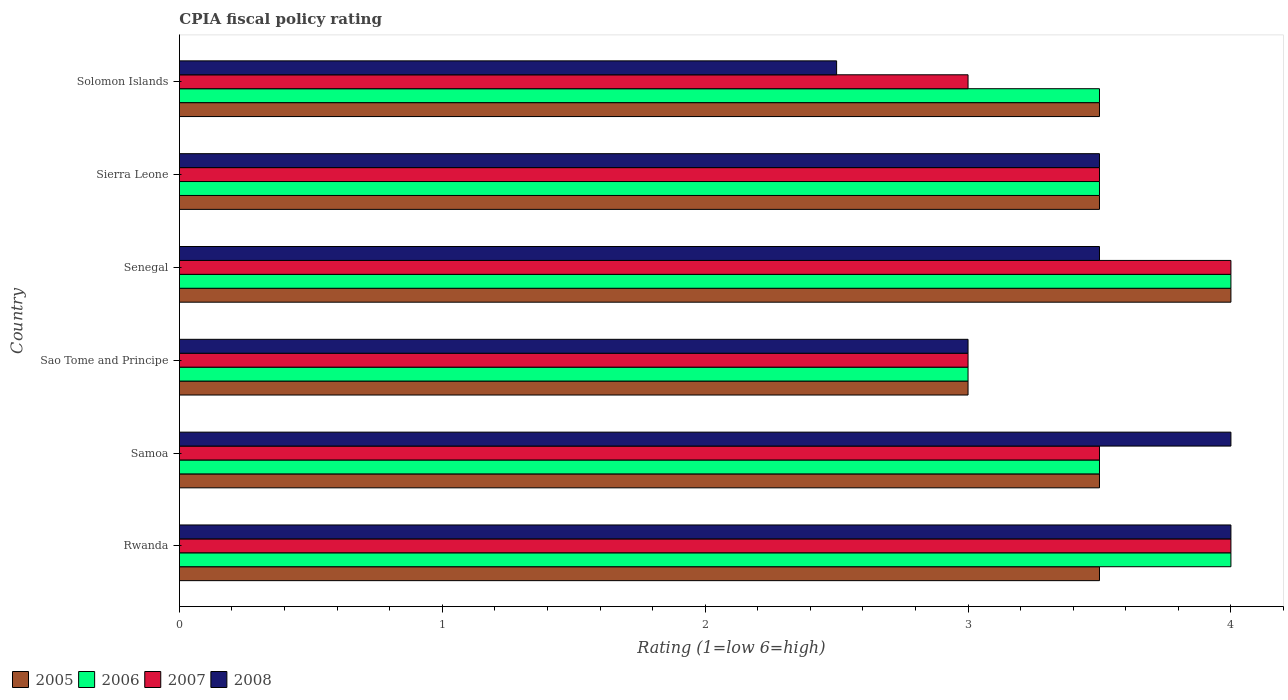How many different coloured bars are there?
Provide a short and direct response. 4. How many groups of bars are there?
Give a very brief answer. 6. How many bars are there on the 2nd tick from the top?
Provide a succinct answer. 4. What is the label of the 4th group of bars from the top?
Your answer should be compact. Sao Tome and Principe. What is the CPIA rating in 2005 in Sierra Leone?
Provide a succinct answer. 3.5. Across all countries, what is the maximum CPIA rating in 2008?
Offer a very short reply. 4. In which country was the CPIA rating in 2008 maximum?
Your answer should be very brief. Rwanda. In which country was the CPIA rating in 2005 minimum?
Provide a short and direct response. Sao Tome and Principe. What is the difference between the CPIA rating in 2008 in Rwanda and that in Samoa?
Your response must be concise. 0. What is the average CPIA rating in 2006 per country?
Provide a succinct answer. 3.58. In how many countries, is the CPIA rating in 2006 greater than 1 ?
Your response must be concise. 6. What is the ratio of the CPIA rating in 2005 in Senegal to that in Sierra Leone?
Make the answer very short. 1.14. Is the difference between the CPIA rating in 2006 in Sierra Leone and Solomon Islands greater than the difference between the CPIA rating in 2008 in Sierra Leone and Solomon Islands?
Make the answer very short. No. What is the difference between the highest and the second highest CPIA rating in 2008?
Keep it short and to the point. 0. What is the difference between the highest and the lowest CPIA rating in 2007?
Give a very brief answer. 1. In how many countries, is the CPIA rating in 2005 greater than the average CPIA rating in 2005 taken over all countries?
Offer a terse response. 1. What does the 2nd bar from the top in Solomon Islands represents?
Your answer should be compact. 2007. What does the 2nd bar from the bottom in Sierra Leone represents?
Keep it short and to the point. 2006. Is it the case that in every country, the sum of the CPIA rating in 2006 and CPIA rating in 2008 is greater than the CPIA rating in 2005?
Ensure brevity in your answer.  Yes. What is the difference between two consecutive major ticks on the X-axis?
Your response must be concise. 1. Does the graph contain any zero values?
Your answer should be very brief. No. Does the graph contain grids?
Provide a succinct answer. No. Where does the legend appear in the graph?
Provide a short and direct response. Bottom left. How are the legend labels stacked?
Your answer should be compact. Horizontal. What is the title of the graph?
Your answer should be compact. CPIA fiscal policy rating. Does "2001" appear as one of the legend labels in the graph?
Your response must be concise. No. What is the Rating (1=low 6=high) in 2005 in Rwanda?
Keep it short and to the point. 3.5. What is the Rating (1=low 6=high) of 2006 in Rwanda?
Make the answer very short. 4. What is the Rating (1=low 6=high) of 2005 in Samoa?
Your answer should be very brief. 3.5. What is the Rating (1=low 6=high) of 2006 in Samoa?
Give a very brief answer. 3.5. What is the Rating (1=low 6=high) in 2008 in Samoa?
Your answer should be very brief. 4. What is the Rating (1=low 6=high) of 2007 in Sao Tome and Principe?
Offer a very short reply. 3. What is the Rating (1=low 6=high) of 2008 in Sao Tome and Principe?
Give a very brief answer. 3. What is the Rating (1=low 6=high) of 2005 in Senegal?
Make the answer very short. 4. What is the Rating (1=low 6=high) in 2007 in Senegal?
Your answer should be very brief. 4. What is the Rating (1=low 6=high) in 2008 in Senegal?
Ensure brevity in your answer.  3.5. What is the Rating (1=low 6=high) in 2005 in Sierra Leone?
Offer a very short reply. 3.5. What is the Rating (1=low 6=high) in 2007 in Sierra Leone?
Provide a succinct answer. 3.5. What is the Rating (1=low 6=high) of 2006 in Solomon Islands?
Provide a short and direct response. 3.5. What is the Rating (1=low 6=high) in 2008 in Solomon Islands?
Keep it short and to the point. 2.5. Across all countries, what is the minimum Rating (1=low 6=high) in 2007?
Ensure brevity in your answer.  3. What is the difference between the Rating (1=low 6=high) of 2006 in Rwanda and that in Samoa?
Provide a succinct answer. 0.5. What is the difference between the Rating (1=low 6=high) of 2008 in Rwanda and that in Samoa?
Offer a very short reply. 0. What is the difference between the Rating (1=low 6=high) in 2006 in Rwanda and that in Sao Tome and Principe?
Ensure brevity in your answer.  1. What is the difference between the Rating (1=low 6=high) of 2008 in Rwanda and that in Sao Tome and Principe?
Keep it short and to the point. 1. What is the difference between the Rating (1=low 6=high) in 2008 in Rwanda and that in Senegal?
Your answer should be very brief. 0.5. What is the difference between the Rating (1=low 6=high) in 2005 in Rwanda and that in Sierra Leone?
Provide a short and direct response. 0. What is the difference between the Rating (1=low 6=high) in 2006 in Rwanda and that in Sierra Leone?
Provide a succinct answer. 0.5. What is the difference between the Rating (1=low 6=high) of 2007 in Rwanda and that in Sierra Leone?
Keep it short and to the point. 0.5. What is the difference between the Rating (1=low 6=high) in 2007 in Rwanda and that in Solomon Islands?
Your answer should be very brief. 1. What is the difference between the Rating (1=low 6=high) of 2005 in Samoa and that in Sao Tome and Principe?
Make the answer very short. 0.5. What is the difference between the Rating (1=low 6=high) in 2007 in Samoa and that in Sao Tome and Principe?
Your answer should be compact. 0.5. What is the difference between the Rating (1=low 6=high) of 2008 in Samoa and that in Sao Tome and Principe?
Give a very brief answer. 1. What is the difference between the Rating (1=low 6=high) in 2006 in Samoa and that in Senegal?
Make the answer very short. -0.5. What is the difference between the Rating (1=low 6=high) in 2007 in Samoa and that in Sierra Leone?
Provide a short and direct response. 0. What is the difference between the Rating (1=low 6=high) in 2005 in Samoa and that in Solomon Islands?
Your answer should be very brief. 0. What is the difference between the Rating (1=low 6=high) of 2006 in Samoa and that in Solomon Islands?
Your answer should be compact. 0. What is the difference between the Rating (1=low 6=high) in 2008 in Samoa and that in Solomon Islands?
Your answer should be compact. 1.5. What is the difference between the Rating (1=low 6=high) of 2006 in Sao Tome and Principe and that in Sierra Leone?
Offer a very short reply. -0.5. What is the difference between the Rating (1=low 6=high) in 2007 in Sao Tome and Principe and that in Sierra Leone?
Give a very brief answer. -0.5. What is the difference between the Rating (1=low 6=high) of 2008 in Sao Tome and Principe and that in Sierra Leone?
Your response must be concise. -0.5. What is the difference between the Rating (1=low 6=high) in 2006 in Sao Tome and Principe and that in Solomon Islands?
Offer a terse response. -0.5. What is the difference between the Rating (1=low 6=high) of 2008 in Sao Tome and Principe and that in Solomon Islands?
Provide a succinct answer. 0.5. What is the difference between the Rating (1=low 6=high) in 2005 in Senegal and that in Sierra Leone?
Ensure brevity in your answer.  0.5. What is the difference between the Rating (1=low 6=high) in 2006 in Senegal and that in Sierra Leone?
Offer a terse response. 0.5. What is the difference between the Rating (1=low 6=high) in 2008 in Senegal and that in Sierra Leone?
Make the answer very short. 0. What is the difference between the Rating (1=low 6=high) of 2007 in Senegal and that in Solomon Islands?
Your response must be concise. 1. What is the difference between the Rating (1=low 6=high) of 2007 in Sierra Leone and that in Solomon Islands?
Offer a terse response. 0.5. What is the difference between the Rating (1=low 6=high) of 2005 in Rwanda and the Rating (1=low 6=high) of 2006 in Samoa?
Provide a succinct answer. 0. What is the difference between the Rating (1=low 6=high) in 2005 in Rwanda and the Rating (1=low 6=high) in 2007 in Samoa?
Provide a succinct answer. 0. What is the difference between the Rating (1=low 6=high) in 2005 in Rwanda and the Rating (1=low 6=high) in 2008 in Samoa?
Provide a short and direct response. -0.5. What is the difference between the Rating (1=low 6=high) in 2006 in Rwanda and the Rating (1=low 6=high) in 2007 in Samoa?
Keep it short and to the point. 0.5. What is the difference between the Rating (1=low 6=high) of 2006 in Rwanda and the Rating (1=low 6=high) of 2008 in Samoa?
Your answer should be compact. 0. What is the difference between the Rating (1=low 6=high) of 2006 in Rwanda and the Rating (1=low 6=high) of 2007 in Sao Tome and Principe?
Provide a short and direct response. 1. What is the difference between the Rating (1=low 6=high) in 2005 in Rwanda and the Rating (1=low 6=high) in 2007 in Senegal?
Provide a short and direct response. -0.5. What is the difference between the Rating (1=low 6=high) in 2005 in Rwanda and the Rating (1=low 6=high) in 2008 in Senegal?
Ensure brevity in your answer.  0. What is the difference between the Rating (1=low 6=high) in 2006 in Rwanda and the Rating (1=low 6=high) in 2008 in Senegal?
Offer a very short reply. 0.5. What is the difference between the Rating (1=low 6=high) of 2007 in Rwanda and the Rating (1=low 6=high) of 2008 in Senegal?
Your response must be concise. 0.5. What is the difference between the Rating (1=low 6=high) in 2006 in Rwanda and the Rating (1=low 6=high) in 2007 in Sierra Leone?
Your response must be concise. 0.5. What is the difference between the Rating (1=low 6=high) in 2006 in Rwanda and the Rating (1=low 6=high) in 2008 in Sierra Leone?
Your answer should be compact. 0.5. What is the difference between the Rating (1=low 6=high) of 2007 in Rwanda and the Rating (1=low 6=high) of 2008 in Sierra Leone?
Your response must be concise. 0.5. What is the difference between the Rating (1=low 6=high) of 2005 in Rwanda and the Rating (1=low 6=high) of 2007 in Solomon Islands?
Make the answer very short. 0.5. What is the difference between the Rating (1=low 6=high) in 2006 in Samoa and the Rating (1=low 6=high) in 2008 in Sao Tome and Principe?
Your answer should be very brief. 0.5. What is the difference between the Rating (1=low 6=high) of 2007 in Samoa and the Rating (1=low 6=high) of 2008 in Sao Tome and Principe?
Give a very brief answer. 0.5. What is the difference between the Rating (1=low 6=high) in 2005 in Samoa and the Rating (1=low 6=high) in 2006 in Senegal?
Provide a succinct answer. -0.5. What is the difference between the Rating (1=low 6=high) of 2005 in Samoa and the Rating (1=low 6=high) of 2007 in Senegal?
Offer a very short reply. -0.5. What is the difference between the Rating (1=low 6=high) in 2005 in Samoa and the Rating (1=low 6=high) in 2008 in Senegal?
Offer a very short reply. 0. What is the difference between the Rating (1=low 6=high) of 2006 in Samoa and the Rating (1=low 6=high) of 2007 in Senegal?
Provide a succinct answer. -0.5. What is the difference between the Rating (1=low 6=high) in 2006 in Samoa and the Rating (1=low 6=high) in 2008 in Senegal?
Give a very brief answer. 0. What is the difference between the Rating (1=low 6=high) of 2005 in Samoa and the Rating (1=low 6=high) of 2007 in Sierra Leone?
Your answer should be compact. 0. What is the difference between the Rating (1=low 6=high) in 2005 in Samoa and the Rating (1=low 6=high) in 2008 in Sierra Leone?
Offer a very short reply. 0. What is the difference between the Rating (1=low 6=high) in 2006 in Samoa and the Rating (1=low 6=high) in 2008 in Sierra Leone?
Your response must be concise. 0. What is the difference between the Rating (1=low 6=high) of 2005 in Samoa and the Rating (1=low 6=high) of 2006 in Solomon Islands?
Offer a very short reply. 0. What is the difference between the Rating (1=low 6=high) in 2006 in Samoa and the Rating (1=low 6=high) in 2008 in Solomon Islands?
Offer a terse response. 1. What is the difference between the Rating (1=low 6=high) in 2007 in Samoa and the Rating (1=low 6=high) in 2008 in Solomon Islands?
Provide a short and direct response. 1. What is the difference between the Rating (1=low 6=high) in 2006 in Sao Tome and Principe and the Rating (1=low 6=high) in 2007 in Senegal?
Provide a succinct answer. -1. What is the difference between the Rating (1=low 6=high) of 2005 in Sao Tome and Principe and the Rating (1=low 6=high) of 2006 in Sierra Leone?
Your response must be concise. -0.5. What is the difference between the Rating (1=low 6=high) of 2005 in Sao Tome and Principe and the Rating (1=low 6=high) of 2008 in Sierra Leone?
Your response must be concise. -0.5. What is the difference between the Rating (1=low 6=high) in 2006 in Sao Tome and Principe and the Rating (1=low 6=high) in 2007 in Sierra Leone?
Keep it short and to the point. -0.5. What is the difference between the Rating (1=low 6=high) of 2006 in Sao Tome and Principe and the Rating (1=low 6=high) of 2008 in Sierra Leone?
Your answer should be very brief. -0.5. What is the difference between the Rating (1=low 6=high) in 2007 in Sao Tome and Principe and the Rating (1=low 6=high) in 2008 in Sierra Leone?
Provide a succinct answer. -0.5. What is the difference between the Rating (1=low 6=high) in 2005 in Sao Tome and Principe and the Rating (1=low 6=high) in 2008 in Solomon Islands?
Offer a very short reply. 0.5. What is the difference between the Rating (1=low 6=high) in 2006 in Sao Tome and Principe and the Rating (1=low 6=high) in 2007 in Solomon Islands?
Provide a short and direct response. 0. What is the difference between the Rating (1=low 6=high) of 2007 in Sao Tome and Principe and the Rating (1=low 6=high) of 2008 in Solomon Islands?
Offer a terse response. 0.5. What is the difference between the Rating (1=low 6=high) of 2005 in Senegal and the Rating (1=low 6=high) of 2007 in Sierra Leone?
Offer a terse response. 0.5. What is the difference between the Rating (1=low 6=high) in 2005 in Senegal and the Rating (1=low 6=high) in 2008 in Sierra Leone?
Ensure brevity in your answer.  0.5. What is the difference between the Rating (1=low 6=high) of 2005 in Senegal and the Rating (1=low 6=high) of 2006 in Solomon Islands?
Make the answer very short. 0.5. What is the difference between the Rating (1=low 6=high) in 2005 in Senegal and the Rating (1=low 6=high) in 2008 in Solomon Islands?
Provide a short and direct response. 1.5. What is the difference between the Rating (1=low 6=high) of 2006 in Senegal and the Rating (1=low 6=high) of 2007 in Solomon Islands?
Give a very brief answer. 1. What is the difference between the Rating (1=low 6=high) of 2006 in Senegal and the Rating (1=low 6=high) of 2008 in Solomon Islands?
Provide a short and direct response. 1.5. What is the difference between the Rating (1=low 6=high) in 2005 in Sierra Leone and the Rating (1=low 6=high) in 2006 in Solomon Islands?
Offer a very short reply. 0. What is the difference between the Rating (1=low 6=high) of 2005 in Sierra Leone and the Rating (1=low 6=high) of 2007 in Solomon Islands?
Keep it short and to the point. 0.5. What is the difference between the Rating (1=low 6=high) in 2005 in Sierra Leone and the Rating (1=low 6=high) in 2008 in Solomon Islands?
Make the answer very short. 1. What is the difference between the Rating (1=low 6=high) in 2007 in Sierra Leone and the Rating (1=low 6=high) in 2008 in Solomon Islands?
Give a very brief answer. 1. What is the average Rating (1=low 6=high) in 2005 per country?
Your answer should be very brief. 3.5. What is the average Rating (1=low 6=high) of 2006 per country?
Your response must be concise. 3.58. What is the average Rating (1=low 6=high) of 2008 per country?
Keep it short and to the point. 3.42. What is the difference between the Rating (1=low 6=high) of 2005 and Rating (1=low 6=high) of 2006 in Rwanda?
Your response must be concise. -0.5. What is the difference between the Rating (1=low 6=high) in 2005 and Rating (1=low 6=high) in 2008 in Rwanda?
Your answer should be compact. -0.5. What is the difference between the Rating (1=low 6=high) in 2006 and Rating (1=low 6=high) in 2007 in Rwanda?
Your response must be concise. 0. What is the difference between the Rating (1=low 6=high) of 2005 and Rating (1=low 6=high) of 2006 in Samoa?
Provide a succinct answer. 0. What is the difference between the Rating (1=low 6=high) in 2006 and Rating (1=low 6=high) in 2007 in Samoa?
Your response must be concise. 0. What is the difference between the Rating (1=low 6=high) in 2005 and Rating (1=low 6=high) in 2006 in Sao Tome and Principe?
Your answer should be compact. 0. What is the difference between the Rating (1=low 6=high) in 2006 and Rating (1=low 6=high) in 2008 in Sao Tome and Principe?
Your answer should be very brief. 0. What is the difference between the Rating (1=low 6=high) of 2005 and Rating (1=low 6=high) of 2006 in Senegal?
Keep it short and to the point. 0. What is the difference between the Rating (1=low 6=high) of 2005 and Rating (1=low 6=high) of 2008 in Senegal?
Your answer should be very brief. 0.5. What is the difference between the Rating (1=low 6=high) of 2006 and Rating (1=low 6=high) of 2007 in Senegal?
Keep it short and to the point. 0. What is the difference between the Rating (1=low 6=high) of 2005 and Rating (1=low 6=high) of 2006 in Sierra Leone?
Offer a terse response. 0. What is the difference between the Rating (1=low 6=high) of 2005 and Rating (1=low 6=high) of 2007 in Sierra Leone?
Provide a succinct answer. 0. What is the difference between the Rating (1=low 6=high) in 2006 and Rating (1=low 6=high) in 2007 in Sierra Leone?
Your response must be concise. 0. What is the difference between the Rating (1=low 6=high) of 2007 and Rating (1=low 6=high) of 2008 in Sierra Leone?
Offer a very short reply. 0. What is the difference between the Rating (1=low 6=high) in 2005 and Rating (1=low 6=high) in 2006 in Solomon Islands?
Offer a very short reply. 0. What is the difference between the Rating (1=low 6=high) in 2005 and Rating (1=low 6=high) in 2007 in Solomon Islands?
Make the answer very short. 0.5. What is the difference between the Rating (1=low 6=high) in 2005 and Rating (1=low 6=high) in 2008 in Solomon Islands?
Ensure brevity in your answer.  1. What is the difference between the Rating (1=low 6=high) of 2006 and Rating (1=low 6=high) of 2007 in Solomon Islands?
Your answer should be compact. 0.5. What is the ratio of the Rating (1=low 6=high) in 2005 in Rwanda to that in Samoa?
Your response must be concise. 1. What is the ratio of the Rating (1=low 6=high) of 2008 in Rwanda to that in Samoa?
Ensure brevity in your answer.  1. What is the ratio of the Rating (1=low 6=high) in 2005 in Rwanda to that in Sao Tome and Principe?
Make the answer very short. 1.17. What is the ratio of the Rating (1=low 6=high) of 2006 in Rwanda to that in Sao Tome and Principe?
Your response must be concise. 1.33. What is the ratio of the Rating (1=low 6=high) in 2006 in Rwanda to that in Sierra Leone?
Make the answer very short. 1.14. What is the ratio of the Rating (1=low 6=high) of 2007 in Rwanda to that in Sierra Leone?
Provide a short and direct response. 1.14. What is the ratio of the Rating (1=low 6=high) of 2008 in Rwanda to that in Sierra Leone?
Give a very brief answer. 1.14. What is the ratio of the Rating (1=low 6=high) of 2005 in Rwanda to that in Solomon Islands?
Your response must be concise. 1. What is the ratio of the Rating (1=low 6=high) in 2007 in Samoa to that in Sao Tome and Principe?
Provide a short and direct response. 1.17. What is the ratio of the Rating (1=low 6=high) of 2007 in Samoa to that in Senegal?
Ensure brevity in your answer.  0.88. What is the ratio of the Rating (1=low 6=high) of 2008 in Samoa to that in Senegal?
Provide a short and direct response. 1.14. What is the ratio of the Rating (1=low 6=high) in 2005 in Samoa to that in Sierra Leone?
Offer a terse response. 1. What is the ratio of the Rating (1=low 6=high) in 2006 in Samoa to that in Solomon Islands?
Ensure brevity in your answer.  1. What is the ratio of the Rating (1=low 6=high) in 2007 in Samoa to that in Solomon Islands?
Offer a very short reply. 1.17. What is the ratio of the Rating (1=low 6=high) of 2008 in Samoa to that in Solomon Islands?
Provide a succinct answer. 1.6. What is the ratio of the Rating (1=low 6=high) of 2006 in Sao Tome and Principe to that in Senegal?
Give a very brief answer. 0.75. What is the ratio of the Rating (1=low 6=high) in 2007 in Sao Tome and Principe to that in Senegal?
Make the answer very short. 0.75. What is the ratio of the Rating (1=low 6=high) of 2008 in Sao Tome and Principe to that in Senegal?
Ensure brevity in your answer.  0.86. What is the ratio of the Rating (1=low 6=high) of 2007 in Sao Tome and Principe to that in Sierra Leone?
Give a very brief answer. 0.86. What is the ratio of the Rating (1=low 6=high) of 2005 in Sao Tome and Principe to that in Solomon Islands?
Ensure brevity in your answer.  0.86. What is the ratio of the Rating (1=low 6=high) of 2006 in Senegal to that in Sierra Leone?
Your answer should be compact. 1.14. What is the ratio of the Rating (1=low 6=high) in 2008 in Senegal to that in Sierra Leone?
Your response must be concise. 1. What is the ratio of the Rating (1=low 6=high) in 2008 in Senegal to that in Solomon Islands?
Offer a terse response. 1.4. What is the ratio of the Rating (1=low 6=high) in 2005 in Sierra Leone to that in Solomon Islands?
Your answer should be very brief. 1. What is the ratio of the Rating (1=low 6=high) of 2008 in Sierra Leone to that in Solomon Islands?
Your response must be concise. 1.4. What is the difference between the highest and the second highest Rating (1=low 6=high) of 2005?
Provide a succinct answer. 0.5. What is the difference between the highest and the second highest Rating (1=low 6=high) in 2006?
Give a very brief answer. 0. What is the difference between the highest and the second highest Rating (1=low 6=high) of 2007?
Provide a succinct answer. 0. What is the difference between the highest and the second highest Rating (1=low 6=high) of 2008?
Offer a very short reply. 0. What is the difference between the highest and the lowest Rating (1=low 6=high) of 2005?
Provide a short and direct response. 1. What is the difference between the highest and the lowest Rating (1=low 6=high) of 2007?
Keep it short and to the point. 1. What is the difference between the highest and the lowest Rating (1=low 6=high) of 2008?
Provide a succinct answer. 1.5. 